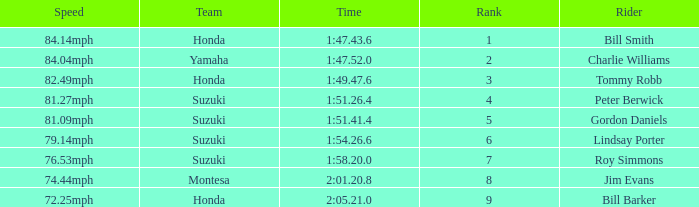I'm looking to parse the entire table for insights. Could you assist me with that? {'header': ['Speed', 'Team', 'Time', 'Rank', 'Rider'], 'rows': [['84.14mph', 'Honda', '1:47.43.6', '1', 'Bill Smith'], ['84.04mph', 'Yamaha', '1:47.52.0', '2', 'Charlie Williams'], ['82.49mph', 'Honda', '1:49.47.6', '3', 'Tommy Robb'], ['81.27mph', 'Suzuki', '1:51.26.4', '4', 'Peter Berwick'], ['81.09mph', 'Suzuki', '1:51.41.4', '5', 'Gordon Daniels'], ['79.14mph', 'Suzuki', '1:54.26.6', '6', 'Lindsay Porter'], ['76.53mph', 'Suzuki', '1:58.20.0', '7', 'Roy Simmons'], ['74.44mph', 'Montesa', '2:01.20.8', '8', 'Jim Evans'], ['72.25mph', 'Honda', '2:05.21.0', '9', 'Bill Barker']]} What was the time for Peter Berwick of Team Suzuki? 1:51.26.4. 